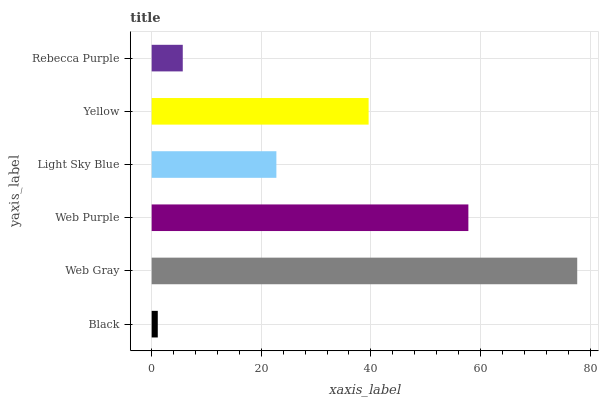Is Black the minimum?
Answer yes or no. Yes. Is Web Gray the maximum?
Answer yes or no. Yes. Is Web Purple the minimum?
Answer yes or no. No. Is Web Purple the maximum?
Answer yes or no. No. Is Web Gray greater than Web Purple?
Answer yes or no. Yes. Is Web Purple less than Web Gray?
Answer yes or no. Yes. Is Web Purple greater than Web Gray?
Answer yes or no. No. Is Web Gray less than Web Purple?
Answer yes or no. No. Is Yellow the high median?
Answer yes or no. Yes. Is Light Sky Blue the low median?
Answer yes or no. Yes. Is Rebecca Purple the high median?
Answer yes or no. No. Is Black the low median?
Answer yes or no. No. 